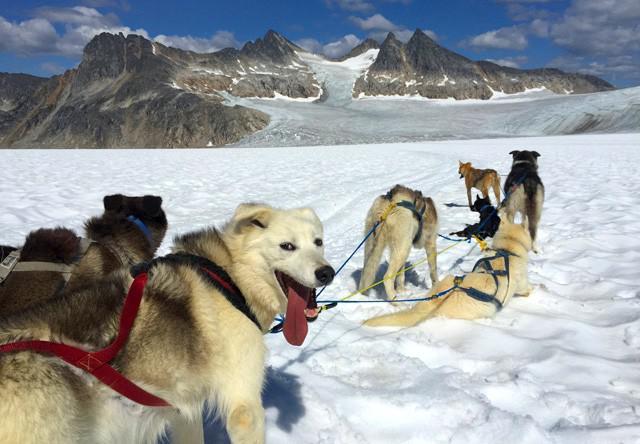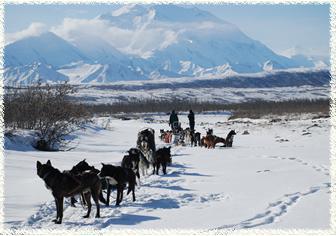The first image is the image on the left, the second image is the image on the right. Examine the images to the left and right. Is the description "There are trees in the image on the left." accurate? Answer yes or no. No. The first image is the image on the left, the second image is the image on the right. Assess this claim about the two images: "An image shows at least one sled but fewer than 3 dogs.". Correct or not? Answer yes or no. No. The first image is the image on the left, the second image is the image on the right. Considering the images on both sides, is "A person in a red and black jacket is in the foreground of one image." valid? Answer yes or no. No. The first image is the image on the left, the second image is the image on the right. For the images shown, is this caption "Three separate teams of sled dogs are harnessed." true? Answer yes or no. Yes. 